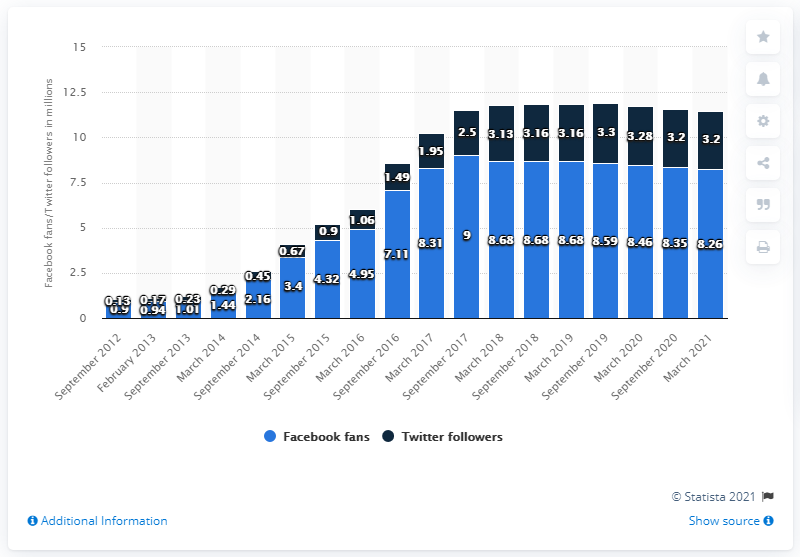Highlight a few significant elements in this photo. In March 2021, the Cleveland Cavaliers had 8,260 Facebook followers. 